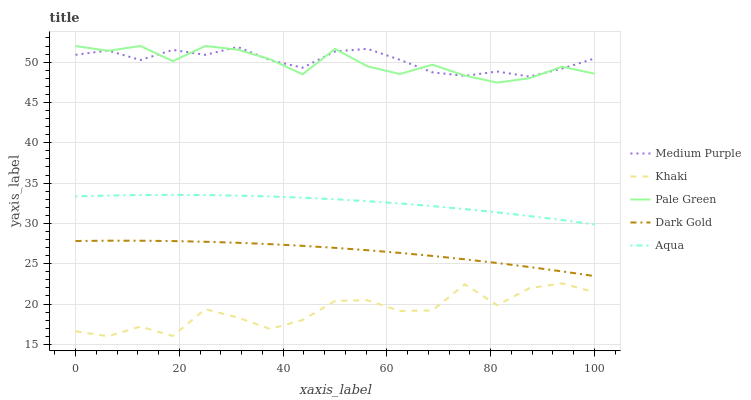Does Khaki have the minimum area under the curve?
Answer yes or no. Yes. Does Medium Purple have the maximum area under the curve?
Answer yes or no. Yes. Does Pale Green have the minimum area under the curve?
Answer yes or no. No. Does Pale Green have the maximum area under the curve?
Answer yes or no. No. Is Dark Gold the smoothest?
Answer yes or no. Yes. Is Khaki the roughest?
Answer yes or no. Yes. Is Pale Green the smoothest?
Answer yes or no. No. Is Pale Green the roughest?
Answer yes or no. No. Does Khaki have the lowest value?
Answer yes or no. Yes. Does Pale Green have the lowest value?
Answer yes or no. No. Does Pale Green have the highest value?
Answer yes or no. Yes. Does Khaki have the highest value?
Answer yes or no. No. Is Aqua less than Pale Green?
Answer yes or no. Yes. Is Medium Purple greater than Aqua?
Answer yes or no. Yes. Does Pale Green intersect Medium Purple?
Answer yes or no. Yes. Is Pale Green less than Medium Purple?
Answer yes or no. No. Is Pale Green greater than Medium Purple?
Answer yes or no. No. Does Aqua intersect Pale Green?
Answer yes or no. No. 